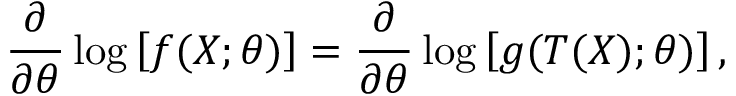Convert formula to latex. <formula><loc_0><loc_0><loc_500><loc_500>{ \frac { \partial } { \partial \theta } } \log \left [ f ( X ; \theta ) \right ] = { \frac { \partial } { \partial \theta } } \log \left [ g ( T ( X ) ; \theta ) \right ] ,</formula> 